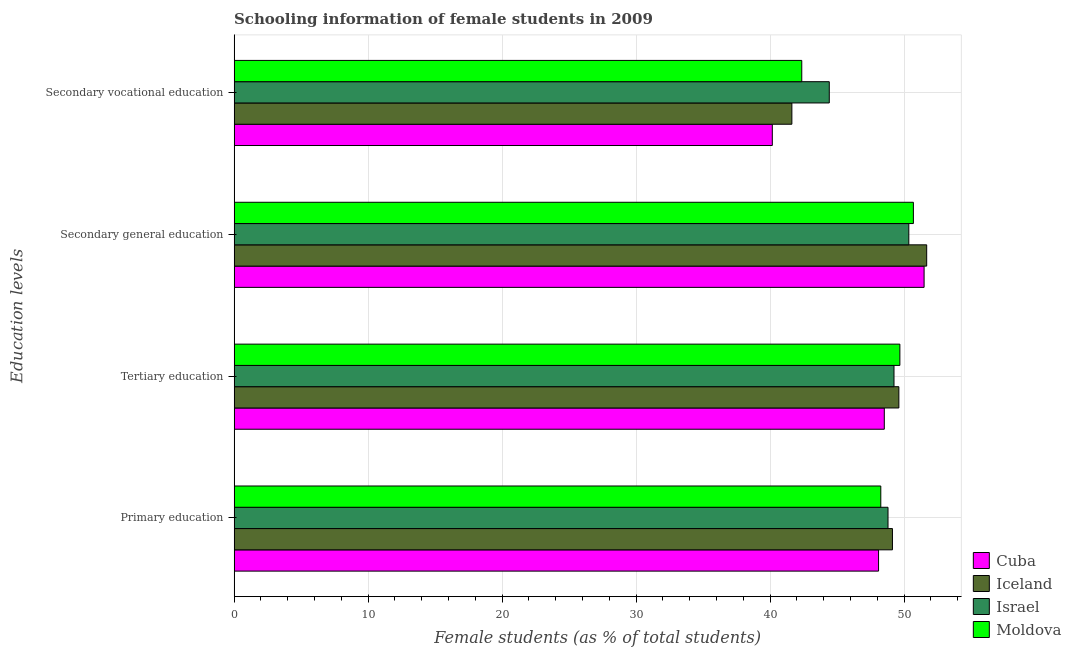How many groups of bars are there?
Ensure brevity in your answer.  4. Are the number of bars per tick equal to the number of legend labels?
Make the answer very short. Yes. How many bars are there on the 3rd tick from the top?
Your answer should be compact. 4. What is the label of the 4th group of bars from the top?
Provide a succinct answer. Primary education. What is the percentage of female students in secondary vocational education in Iceland?
Your answer should be compact. 41.62. Across all countries, what is the maximum percentage of female students in secondary vocational education?
Provide a short and direct response. 44.42. Across all countries, what is the minimum percentage of female students in secondary vocational education?
Your answer should be very brief. 40.16. In which country was the percentage of female students in secondary vocational education maximum?
Offer a terse response. Israel. In which country was the percentage of female students in secondary education minimum?
Make the answer very short. Israel. What is the total percentage of female students in primary education in the graph?
Offer a very short reply. 194.28. What is the difference between the percentage of female students in secondary education in Israel and that in Iceland?
Provide a short and direct response. -1.33. What is the difference between the percentage of female students in tertiary education in Israel and the percentage of female students in secondary education in Iceland?
Keep it short and to the point. -2.44. What is the average percentage of female students in secondary vocational education per country?
Give a very brief answer. 42.14. What is the difference between the percentage of female students in primary education and percentage of female students in secondary education in Cuba?
Ensure brevity in your answer.  -3.4. What is the ratio of the percentage of female students in secondary education in Israel to that in Cuba?
Make the answer very short. 0.98. Is the difference between the percentage of female students in secondary vocational education in Israel and Cuba greater than the difference between the percentage of female students in primary education in Israel and Cuba?
Ensure brevity in your answer.  Yes. What is the difference between the highest and the second highest percentage of female students in tertiary education?
Give a very brief answer. 0.08. What is the difference between the highest and the lowest percentage of female students in secondary vocational education?
Offer a terse response. 4.25. In how many countries, is the percentage of female students in tertiary education greater than the average percentage of female students in tertiary education taken over all countries?
Provide a short and direct response. 2. What does the 4th bar from the top in Secondary vocational education represents?
Your response must be concise. Cuba. What does the 1st bar from the bottom in Secondary vocational education represents?
Your response must be concise. Cuba. Is it the case that in every country, the sum of the percentage of female students in primary education and percentage of female students in tertiary education is greater than the percentage of female students in secondary education?
Your response must be concise. Yes. How many bars are there?
Give a very brief answer. 16. Does the graph contain any zero values?
Give a very brief answer. No. Where does the legend appear in the graph?
Ensure brevity in your answer.  Bottom right. What is the title of the graph?
Provide a succinct answer. Schooling information of female students in 2009. Does "Northern Mariana Islands" appear as one of the legend labels in the graph?
Make the answer very short. No. What is the label or title of the X-axis?
Offer a terse response. Female students (as % of total students). What is the label or title of the Y-axis?
Provide a succinct answer. Education levels. What is the Female students (as % of total students) of Cuba in Primary education?
Your answer should be compact. 48.09. What is the Female students (as % of total students) in Iceland in Primary education?
Make the answer very short. 49.13. What is the Female students (as % of total students) in Israel in Primary education?
Keep it short and to the point. 48.8. What is the Female students (as % of total students) of Moldova in Primary education?
Provide a succinct answer. 48.26. What is the Female students (as % of total students) of Cuba in Tertiary education?
Ensure brevity in your answer.  48.52. What is the Female students (as % of total students) in Iceland in Tertiary education?
Ensure brevity in your answer.  49.61. What is the Female students (as % of total students) of Israel in Tertiary education?
Your answer should be compact. 49.25. What is the Female students (as % of total students) in Moldova in Tertiary education?
Keep it short and to the point. 49.68. What is the Female students (as % of total students) of Cuba in Secondary general education?
Make the answer very short. 51.49. What is the Female students (as % of total students) in Iceland in Secondary general education?
Provide a short and direct response. 51.68. What is the Female students (as % of total students) of Israel in Secondary general education?
Ensure brevity in your answer.  50.35. What is the Female students (as % of total students) of Moldova in Secondary general education?
Offer a terse response. 50.69. What is the Female students (as % of total students) in Cuba in Secondary vocational education?
Offer a very short reply. 40.16. What is the Female students (as % of total students) in Iceland in Secondary vocational education?
Offer a very short reply. 41.62. What is the Female students (as % of total students) of Israel in Secondary vocational education?
Ensure brevity in your answer.  44.42. What is the Female students (as % of total students) in Moldova in Secondary vocational education?
Ensure brevity in your answer.  42.36. Across all Education levels, what is the maximum Female students (as % of total students) in Cuba?
Offer a very short reply. 51.49. Across all Education levels, what is the maximum Female students (as % of total students) of Iceland?
Offer a very short reply. 51.68. Across all Education levels, what is the maximum Female students (as % of total students) of Israel?
Offer a terse response. 50.35. Across all Education levels, what is the maximum Female students (as % of total students) in Moldova?
Give a very brief answer. 50.69. Across all Education levels, what is the minimum Female students (as % of total students) of Cuba?
Keep it short and to the point. 40.16. Across all Education levels, what is the minimum Female students (as % of total students) in Iceland?
Provide a short and direct response. 41.62. Across all Education levels, what is the minimum Female students (as % of total students) of Israel?
Offer a terse response. 44.42. Across all Education levels, what is the minimum Female students (as % of total students) in Moldova?
Your response must be concise. 42.36. What is the total Female students (as % of total students) in Cuba in the graph?
Offer a terse response. 188.27. What is the total Female students (as % of total students) of Iceland in the graph?
Your answer should be very brief. 192.05. What is the total Female students (as % of total students) in Israel in the graph?
Offer a very short reply. 192.81. What is the total Female students (as % of total students) in Moldova in the graph?
Keep it short and to the point. 191. What is the difference between the Female students (as % of total students) in Cuba in Primary education and that in Tertiary education?
Offer a very short reply. -0.43. What is the difference between the Female students (as % of total students) in Iceland in Primary education and that in Tertiary education?
Offer a very short reply. -0.48. What is the difference between the Female students (as % of total students) of Israel in Primary education and that in Tertiary education?
Keep it short and to the point. -0.45. What is the difference between the Female students (as % of total students) of Moldova in Primary education and that in Tertiary education?
Provide a short and direct response. -1.42. What is the difference between the Female students (as % of total students) of Cuba in Primary education and that in Secondary general education?
Keep it short and to the point. -3.4. What is the difference between the Female students (as % of total students) in Iceland in Primary education and that in Secondary general education?
Provide a succinct answer. -2.56. What is the difference between the Female students (as % of total students) in Israel in Primary education and that in Secondary general education?
Ensure brevity in your answer.  -1.55. What is the difference between the Female students (as % of total students) in Moldova in Primary education and that in Secondary general education?
Your response must be concise. -2.43. What is the difference between the Female students (as % of total students) of Cuba in Primary education and that in Secondary vocational education?
Keep it short and to the point. 7.93. What is the difference between the Female students (as % of total students) of Iceland in Primary education and that in Secondary vocational education?
Your answer should be compact. 7.51. What is the difference between the Female students (as % of total students) in Israel in Primary education and that in Secondary vocational education?
Provide a short and direct response. 4.38. What is the difference between the Female students (as % of total students) of Moldova in Primary education and that in Secondary vocational education?
Ensure brevity in your answer.  5.9. What is the difference between the Female students (as % of total students) of Cuba in Tertiary education and that in Secondary general education?
Ensure brevity in your answer.  -2.97. What is the difference between the Female students (as % of total students) in Iceland in Tertiary education and that in Secondary general education?
Ensure brevity in your answer.  -2.08. What is the difference between the Female students (as % of total students) in Israel in Tertiary education and that in Secondary general education?
Your answer should be compact. -1.1. What is the difference between the Female students (as % of total students) in Moldova in Tertiary education and that in Secondary general education?
Ensure brevity in your answer.  -1.01. What is the difference between the Female students (as % of total students) in Cuba in Tertiary education and that in Secondary vocational education?
Make the answer very short. 8.36. What is the difference between the Female students (as % of total students) of Iceland in Tertiary education and that in Secondary vocational education?
Offer a terse response. 7.98. What is the difference between the Female students (as % of total students) in Israel in Tertiary education and that in Secondary vocational education?
Keep it short and to the point. 4.83. What is the difference between the Female students (as % of total students) of Moldova in Tertiary education and that in Secondary vocational education?
Your answer should be very brief. 7.32. What is the difference between the Female students (as % of total students) in Cuba in Secondary general education and that in Secondary vocational education?
Ensure brevity in your answer.  11.33. What is the difference between the Female students (as % of total students) in Iceland in Secondary general education and that in Secondary vocational education?
Offer a terse response. 10.06. What is the difference between the Female students (as % of total students) in Israel in Secondary general education and that in Secondary vocational education?
Your response must be concise. 5.93. What is the difference between the Female students (as % of total students) of Moldova in Secondary general education and that in Secondary vocational education?
Offer a very short reply. 8.33. What is the difference between the Female students (as % of total students) in Cuba in Primary education and the Female students (as % of total students) in Iceland in Tertiary education?
Your answer should be very brief. -1.51. What is the difference between the Female students (as % of total students) of Cuba in Primary education and the Female students (as % of total students) of Israel in Tertiary education?
Make the answer very short. -1.15. What is the difference between the Female students (as % of total students) of Cuba in Primary education and the Female students (as % of total students) of Moldova in Tertiary education?
Keep it short and to the point. -1.59. What is the difference between the Female students (as % of total students) in Iceland in Primary education and the Female students (as % of total students) in Israel in Tertiary education?
Give a very brief answer. -0.12. What is the difference between the Female students (as % of total students) in Iceland in Primary education and the Female students (as % of total students) in Moldova in Tertiary education?
Offer a very short reply. -0.55. What is the difference between the Female students (as % of total students) of Israel in Primary education and the Female students (as % of total students) of Moldova in Tertiary education?
Your answer should be compact. -0.89. What is the difference between the Female students (as % of total students) in Cuba in Primary education and the Female students (as % of total students) in Iceland in Secondary general education?
Give a very brief answer. -3.59. What is the difference between the Female students (as % of total students) of Cuba in Primary education and the Female students (as % of total students) of Israel in Secondary general education?
Give a very brief answer. -2.26. What is the difference between the Female students (as % of total students) of Cuba in Primary education and the Female students (as % of total students) of Moldova in Secondary general education?
Provide a short and direct response. -2.6. What is the difference between the Female students (as % of total students) in Iceland in Primary education and the Female students (as % of total students) in Israel in Secondary general education?
Offer a very short reply. -1.22. What is the difference between the Female students (as % of total students) in Iceland in Primary education and the Female students (as % of total students) in Moldova in Secondary general education?
Keep it short and to the point. -1.56. What is the difference between the Female students (as % of total students) in Israel in Primary education and the Female students (as % of total students) in Moldova in Secondary general education?
Provide a short and direct response. -1.89. What is the difference between the Female students (as % of total students) of Cuba in Primary education and the Female students (as % of total students) of Iceland in Secondary vocational education?
Make the answer very short. 6.47. What is the difference between the Female students (as % of total students) of Cuba in Primary education and the Female students (as % of total students) of Israel in Secondary vocational education?
Keep it short and to the point. 3.68. What is the difference between the Female students (as % of total students) of Cuba in Primary education and the Female students (as % of total students) of Moldova in Secondary vocational education?
Make the answer very short. 5.73. What is the difference between the Female students (as % of total students) in Iceland in Primary education and the Female students (as % of total students) in Israel in Secondary vocational education?
Give a very brief answer. 4.71. What is the difference between the Female students (as % of total students) in Iceland in Primary education and the Female students (as % of total students) in Moldova in Secondary vocational education?
Your response must be concise. 6.77. What is the difference between the Female students (as % of total students) of Israel in Primary education and the Female students (as % of total students) of Moldova in Secondary vocational education?
Make the answer very short. 6.44. What is the difference between the Female students (as % of total students) of Cuba in Tertiary education and the Female students (as % of total students) of Iceland in Secondary general education?
Your response must be concise. -3.16. What is the difference between the Female students (as % of total students) in Cuba in Tertiary education and the Female students (as % of total students) in Israel in Secondary general education?
Give a very brief answer. -1.83. What is the difference between the Female students (as % of total students) of Cuba in Tertiary education and the Female students (as % of total students) of Moldova in Secondary general education?
Give a very brief answer. -2.17. What is the difference between the Female students (as % of total students) of Iceland in Tertiary education and the Female students (as % of total students) of Israel in Secondary general education?
Make the answer very short. -0.74. What is the difference between the Female students (as % of total students) of Iceland in Tertiary education and the Female students (as % of total students) of Moldova in Secondary general education?
Provide a succinct answer. -1.08. What is the difference between the Female students (as % of total students) of Israel in Tertiary education and the Female students (as % of total students) of Moldova in Secondary general education?
Provide a succinct answer. -1.45. What is the difference between the Female students (as % of total students) in Cuba in Tertiary education and the Female students (as % of total students) in Iceland in Secondary vocational education?
Provide a succinct answer. 6.9. What is the difference between the Female students (as % of total students) of Cuba in Tertiary education and the Female students (as % of total students) of Israel in Secondary vocational education?
Give a very brief answer. 4.11. What is the difference between the Female students (as % of total students) in Cuba in Tertiary education and the Female students (as % of total students) in Moldova in Secondary vocational education?
Offer a terse response. 6.16. What is the difference between the Female students (as % of total students) in Iceland in Tertiary education and the Female students (as % of total students) in Israel in Secondary vocational education?
Provide a short and direct response. 5.19. What is the difference between the Female students (as % of total students) of Iceland in Tertiary education and the Female students (as % of total students) of Moldova in Secondary vocational education?
Your answer should be very brief. 7.25. What is the difference between the Female students (as % of total students) of Israel in Tertiary education and the Female students (as % of total students) of Moldova in Secondary vocational education?
Provide a succinct answer. 6.88. What is the difference between the Female students (as % of total students) in Cuba in Secondary general education and the Female students (as % of total students) in Iceland in Secondary vocational education?
Offer a very short reply. 9.87. What is the difference between the Female students (as % of total students) in Cuba in Secondary general education and the Female students (as % of total students) in Israel in Secondary vocational education?
Give a very brief answer. 7.08. What is the difference between the Female students (as % of total students) in Cuba in Secondary general education and the Female students (as % of total students) in Moldova in Secondary vocational education?
Your answer should be compact. 9.13. What is the difference between the Female students (as % of total students) of Iceland in Secondary general education and the Female students (as % of total students) of Israel in Secondary vocational education?
Provide a short and direct response. 7.27. What is the difference between the Female students (as % of total students) of Iceland in Secondary general education and the Female students (as % of total students) of Moldova in Secondary vocational education?
Give a very brief answer. 9.32. What is the difference between the Female students (as % of total students) in Israel in Secondary general education and the Female students (as % of total students) in Moldova in Secondary vocational education?
Provide a short and direct response. 7.99. What is the average Female students (as % of total students) in Cuba per Education levels?
Your response must be concise. 47.07. What is the average Female students (as % of total students) in Iceland per Education levels?
Offer a very short reply. 48.01. What is the average Female students (as % of total students) in Israel per Education levels?
Keep it short and to the point. 48.2. What is the average Female students (as % of total students) of Moldova per Education levels?
Your answer should be very brief. 47.75. What is the difference between the Female students (as % of total students) of Cuba and Female students (as % of total students) of Iceland in Primary education?
Ensure brevity in your answer.  -1.04. What is the difference between the Female students (as % of total students) of Cuba and Female students (as % of total students) of Israel in Primary education?
Offer a terse response. -0.7. What is the difference between the Female students (as % of total students) in Cuba and Female students (as % of total students) in Moldova in Primary education?
Ensure brevity in your answer.  -0.17. What is the difference between the Female students (as % of total students) of Iceland and Female students (as % of total students) of Israel in Primary education?
Your response must be concise. 0.33. What is the difference between the Female students (as % of total students) in Iceland and Female students (as % of total students) in Moldova in Primary education?
Your answer should be very brief. 0.87. What is the difference between the Female students (as % of total students) of Israel and Female students (as % of total students) of Moldova in Primary education?
Provide a succinct answer. 0.54. What is the difference between the Female students (as % of total students) of Cuba and Female students (as % of total students) of Iceland in Tertiary education?
Make the answer very short. -1.09. What is the difference between the Female students (as % of total students) of Cuba and Female students (as % of total students) of Israel in Tertiary education?
Your answer should be compact. -0.72. What is the difference between the Female students (as % of total students) of Cuba and Female students (as % of total students) of Moldova in Tertiary education?
Your answer should be compact. -1.16. What is the difference between the Female students (as % of total students) in Iceland and Female students (as % of total students) in Israel in Tertiary education?
Ensure brevity in your answer.  0.36. What is the difference between the Female students (as % of total students) in Iceland and Female students (as % of total students) in Moldova in Tertiary education?
Your answer should be compact. -0.08. What is the difference between the Female students (as % of total students) of Israel and Female students (as % of total students) of Moldova in Tertiary education?
Provide a short and direct response. -0.44. What is the difference between the Female students (as % of total students) of Cuba and Female students (as % of total students) of Iceland in Secondary general education?
Your answer should be very brief. -0.19. What is the difference between the Female students (as % of total students) in Cuba and Female students (as % of total students) in Israel in Secondary general education?
Your answer should be very brief. 1.14. What is the difference between the Female students (as % of total students) in Cuba and Female students (as % of total students) in Moldova in Secondary general education?
Your response must be concise. 0.8. What is the difference between the Female students (as % of total students) in Iceland and Female students (as % of total students) in Israel in Secondary general education?
Keep it short and to the point. 1.33. What is the difference between the Female students (as % of total students) of Iceland and Female students (as % of total students) of Moldova in Secondary general education?
Provide a short and direct response. 0.99. What is the difference between the Female students (as % of total students) of Israel and Female students (as % of total students) of Moldova in Secondary general education?
Keep it short and to the point. -0.34. What is the difference between the Female students (as % of total students) of Cuba and Female students (as % of total students) of Iceland in Secondary vocational education?
Ensure brevity in your answer.  -1.46. What is the difference between the Female students (as % of total students) in Cuba and Female students (as % of total students) in Israel in Secondary vocational education?
Your answer should be compact. -4.25. What is the difference between the Female students (as % of total students) in Cuba and Female students (as % of total students) in Moldova in Secondary vocational education?
Keep it short and to the point. -2.2. What is the difference between the Female students (as % of total students) of Iceland and Female students (as % of total students) of Israel in Secondary vocational education?
Provide a succinct answer. -2.79. What is the difference between the Female students (as % of total students) of Iceland and Female students (as % of total students) of Moldova in Secondary vocational education?
Offer a terse response. -0.74. What is the difference between the Female students (as % of total students) of Israel and Female students (as % of total students) of Moldova in Secondary vocational education?
Your answer should be very brief. 2.05. What is the ratio of the Female students (as % of total students) of Cuba in Primary education to that in Tertiary education?
Your response must be concise. 0.99. What is the ratio of the Female students (as % of total students) of Iceland in Primary education to that in Tertiary education?
Give a very brief answer. 0.99. What is the ratio of the Female students (as % of total students) of Israel in Primary education to that in Tertiary education?
Offer a terse response. 0.99. What is the ratio of the Female students (as % of total students) of Moldova in Primary education to that in Tertiary education?
Keep it short and to the point. 0.97. What is the ratio of the Female students (as % of total students) in Cuba in Primary education to that in Secondary general education?
Offer a terse response. 0.93. What is the ratio of the Female students (as % of total students) in Iceland in Primary education to that in Secondary general education?
Keep it short and to the point. 0.95. What is the ratio of the Female students (as % of total students) of Israel in Primary education to that in Secondary general education?
Offer a terse response. 0.97. What is the ratio of the Female students (as % of total students) of Cuba in Primary education to that in Secondary vocational education?
Give a very brief answer. 1.2. What is the ratio of the Female students (as % of total students) of Iceland in Primary education to that in Secondary vocational education?
Your answer should be compact. 1.18. What is the ratio of the Female students (as % of total students) in Israel in Primary education to that in Secondary vocational education?
Keep it short and to the point. 1.1. What is the ratio of the Female students (as % of total students) of Moldova in Primary education to that in Secondary vocational education?
Your answer should be very brief. 1.14. What is the ratio of the Female students (as % of total students) in Cuba in Tertiary education to that in Secondary general education?
Ensure brevity in your answer.  0.94. What is the ratio of the Female students (as % of total students) in Iceland in Tertiary education to that in Secondary general education?
Ensure brevity in your answer.  0.96. What is the ratio of the Female students (as % of total students) in Israel in Tertiary education to that in Secondary general education?
Provide a short and direct response. 0.98. What is the ratio of the Female students (as % of total students) in Moldova in Tertiary education to that in Secondary general education?
Offer a very short reply. 0.98. What is the ratio of the Female students (as % of total students) of Cuba in Tertiary education to that in Secondary vocational education?
Provide a short and direct response. 1.21. What is the ratio of the Female students (as % of total students) in Iceland in Tertiary education to that in Secondary vocational education?
Make the answer very short. 1.19. What is the ratio of the Female students (as % of total students) of Israel in Tertiary education to that in Secondary vocational education?
Your response must be concise. 1.11. What is the ratio of the Female students (as % of total students) of Moldova in Tertiary education to that in Secondary vocational education?
Your answer should be compact. 1.17. What is the ratio of the Female students (as % of total students) in Cuba in Secondary general education to that in Secondary vocational education?
Give a very brief answer. 1.28. What is the ratio of the Female students (as % of total students) in Iceland in Secondary general education to that in Secondary vocational education?
Ensure brevity in your answer.  1.24. What is the ratio of the Female students (as % of total students) of Israel in Secondary general education to that in Secondary vocational education?
Provide a succinct answer. 1.13. What is the ratio of the Female students (as % of total students) in Moldova in Secondary general education to that in Secondary vocational education?
Offer a terse response. 1.2. What is the difference between the highest and the second highest Female students (as % of total students) in Cuba?
Offer a very short reply. 2.97. What is the difference between the highest and the second highest Female students (as % of total students) in Iceland?
Ensure brevity in your answer.  2.08. What is the difference between the highest and the second highest Female students (as % of total students) in Israel?
Your response must be concise. 1.1. What is the difference between the highest and the second highest Female students (as % of total students) in Moldova?
Offer a very short reply. 1.01. What is the difference between the highest and the lowest Female students (as % of total students) of Cuba?
Offer a terse response. 11.33. What is the difference between the highest and the lowest Female students (as % of total students) of Iceland?
Your answer should be very brief. 10.06. What is the difference between the highest and the lowest Female students (as % of total students) in Israel?
Provide a short and direct response. 5.93. What is the difference between the highest and the lowest Female students (as % of total students) in Moldova?
Make the answer very short. 8.33. 